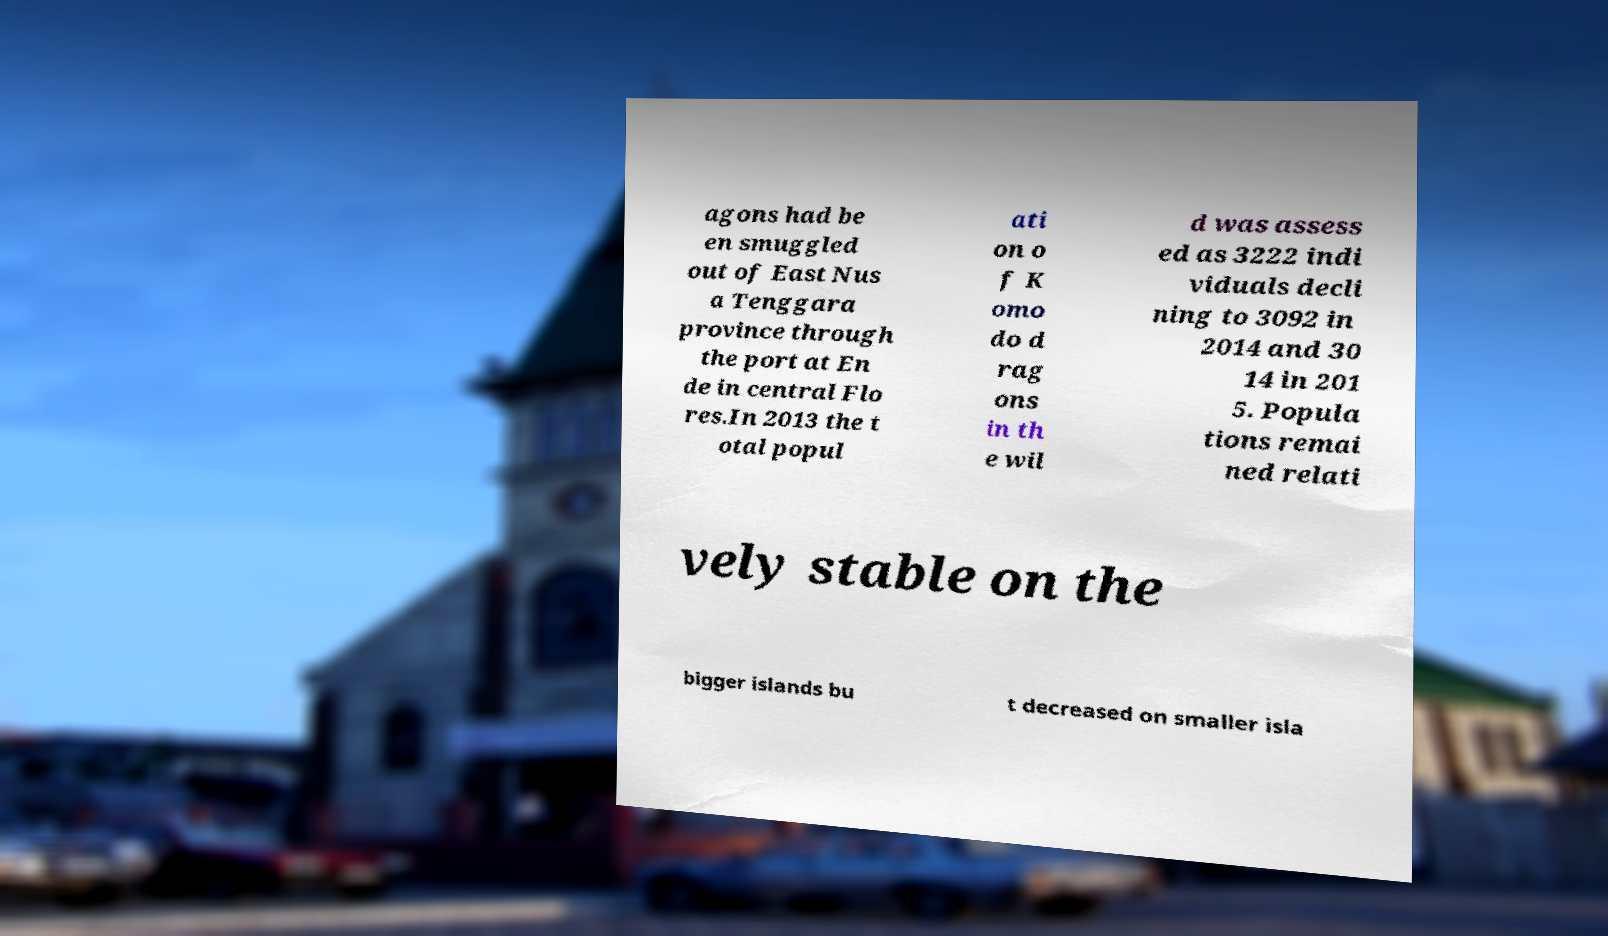I need the written content from this picture converted into text. Can you do that? agons had be en smuggled out of East Nus a Tenggara province through the port at En de in central Flo res.In 2013 the t otal popul ati on o f K omo do d rag ons in th e wil d was assess ed as 3222 indi viduals decli ning to 3092 in 2014 and 30 14 in 201 5. Popula tions remai ned relati vely stable on the bigger islands bu t decreased on smaller isla 